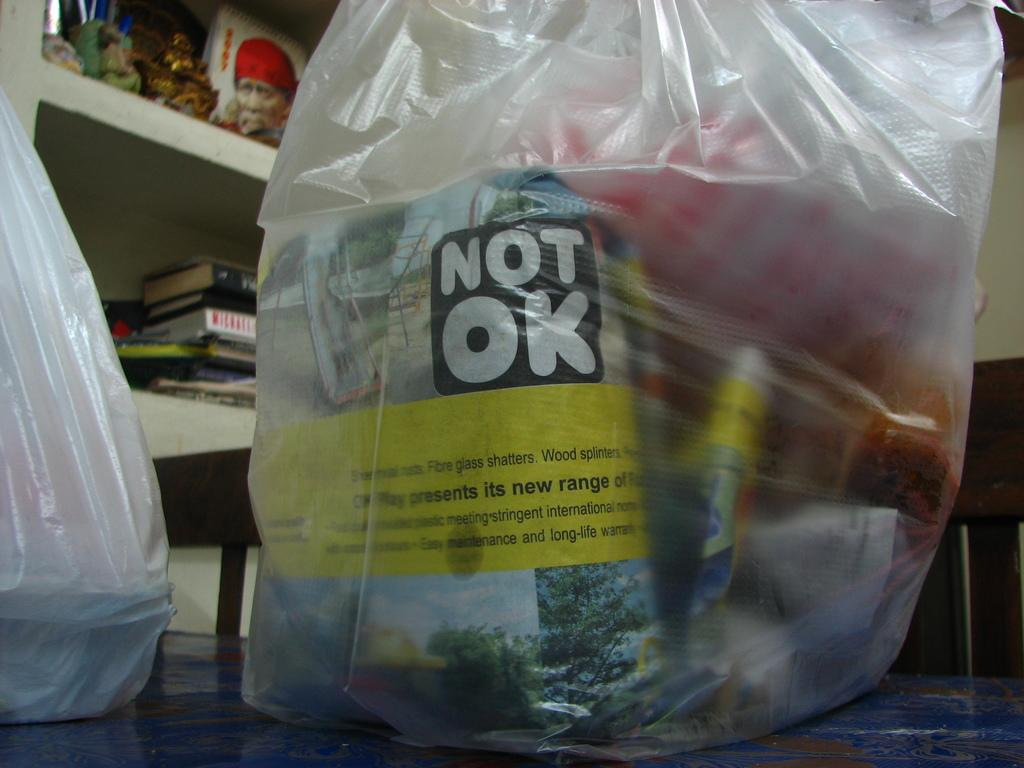What type of covers are present in the image? There are plastic covers in the image. What can be seen under the plastic covers? There are objects visible under the plastic covers. What type of image is present in the photo? There is a photo of a god in the image. What type of items can be seen in the image besides the plastic covers and photo? There are books in the image. How many apples are placed on the shirt in the image? There is no shirt or apples present in the image. 